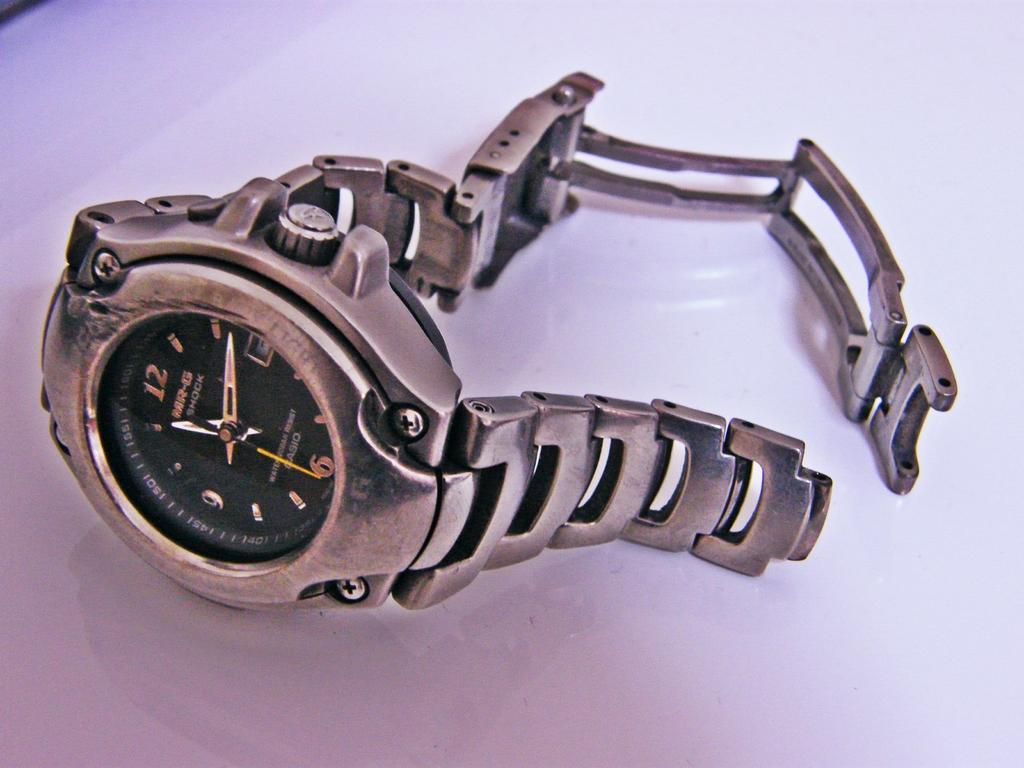Provide a one-sentence caption for the provided image. A broken Casio MR-G Shock watch is laying on the counter. 